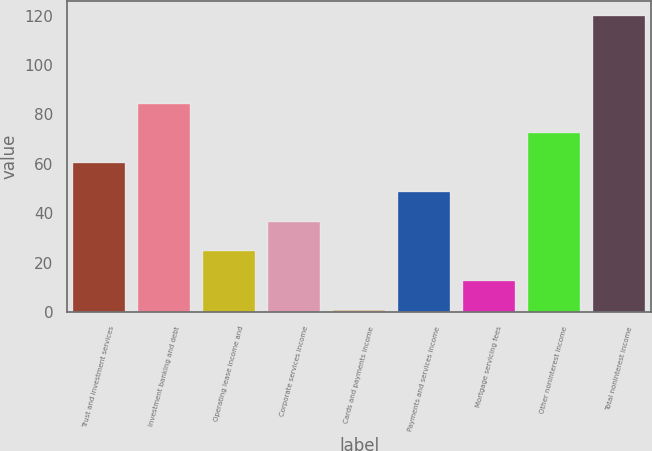Convert chart. <chart><loc_0><loc_0><loc_500><loc_500><bar_chart><fcel>Trust and investment services<fcel>Investment banking and debt<fcel>Operating lease income and<fcel>Corporate services income<fcel>Cards and payments income<fcel>Payments and services income<fcel>Mortgage servicing fees<fcel>Other noninterest income<fcel>Total noninterest income<nl><fcel>60.5<fcel>84.3<fcel>24.8<fcel>36.7<fcel>1<fcel>48.6<fcel>12.9<fcel>72.4<fcel>120<nl></chart> 